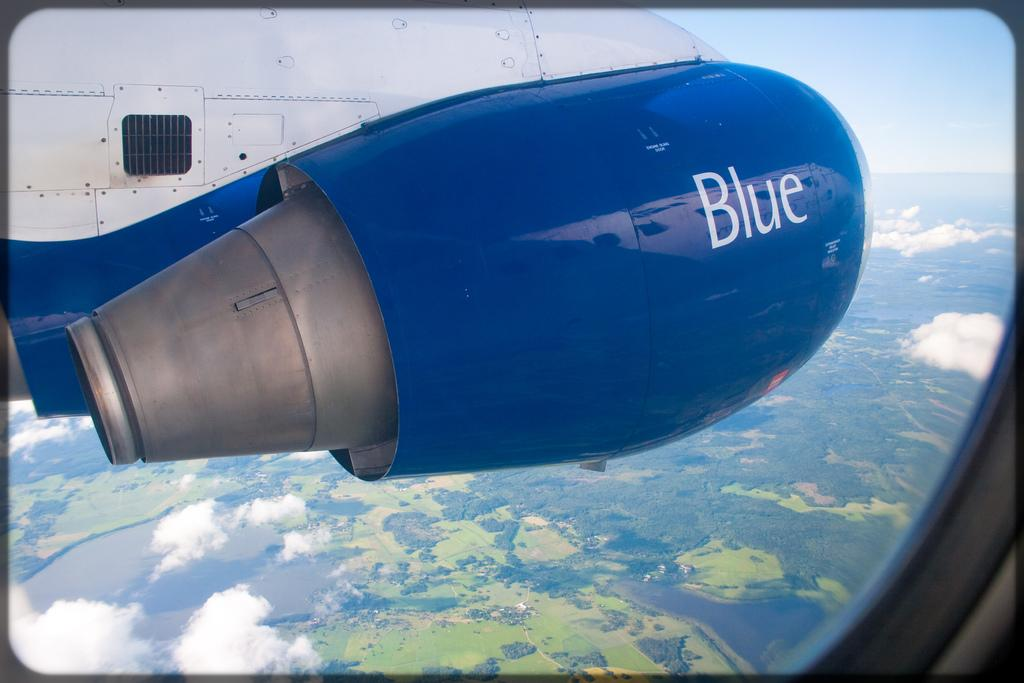<image>
Create a compact narrative representing the image presented. the outside of an airplane that says the world blue 